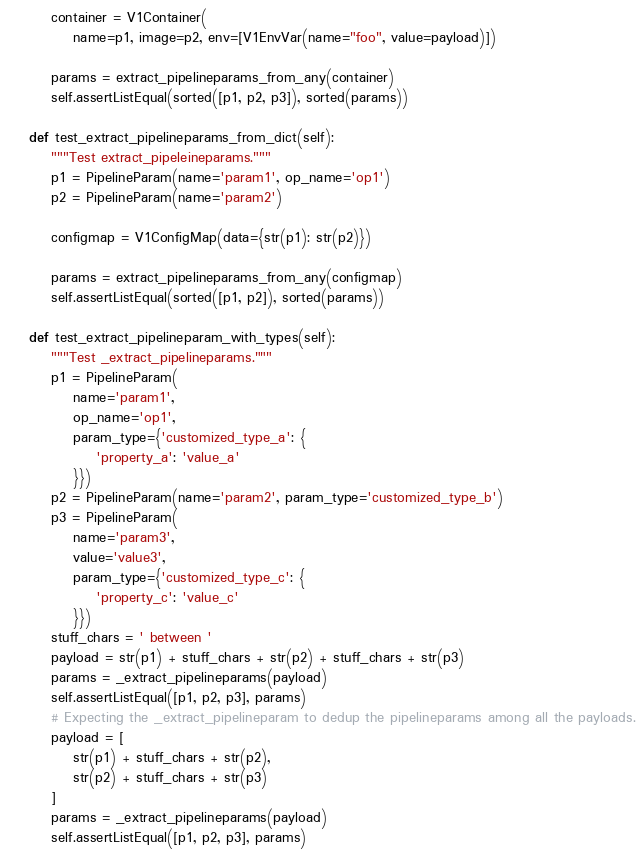<code> <loc_0><loc_0><loc_500><loc_500><_Python_>        container = V1Container(
            name=p1, image=p2, env=[V1EnvVar(name="foo", value=payload)])

        params = extract_pipelineparams_from_any(container)
        self.assertListEqual(sorted([p1, p2, p3]), sorted(params))

    def test_extract_pipelineparams_from_dict(self):
        """Test extract_pipeleineparams."""
        p1 = PipelineParam(name='param1', op_name='op1')
        p2 = PipelineParam(name='param2')

        configmap = V1ConfigMap(data={str(p1): str(p2)})

        params = extract_pipelineparams_from_any(configmap)
        self.assertListEqual(sorted([p1, p2]), sorted(params))

    def test_extract_pipelineparam_with_types(self):
        """Test _extract_pipelineparams."""
        p1 = PipelineParam(
            name='param1',
            op_name='op1',
            param_type={'customized_type_a': {
                'property_a': 'value_a'
            }})
        p2 = PipelineParam(name='param2', param_type='customized_type_b')
        p3 = PipelineParam(
            name='param3',
            value='value3',
            param_type={'customized_type_c': {
                'property_c': 'value_c'
            }})
        stuff_chars = ' between '
        payload = str(p1) + stuff_chars + str(p2) + stuff_chars + str(p3)
        params = _extract_pipelineparams(payload)
        self.assertListEqual([p1, p2, p3], params)
        # Expecting the _extract_pipelineparam to dedup the pipelineparams among all the payloads.
        payload = [
            str(p1) + stuff_chars + str(p2),
            str(p2) + stuff_chars + str(p3)
        ]
        params = _extract_pipelineparams(payload)
        self.assertListEqual([p1, p2, p3], params)
</code> 